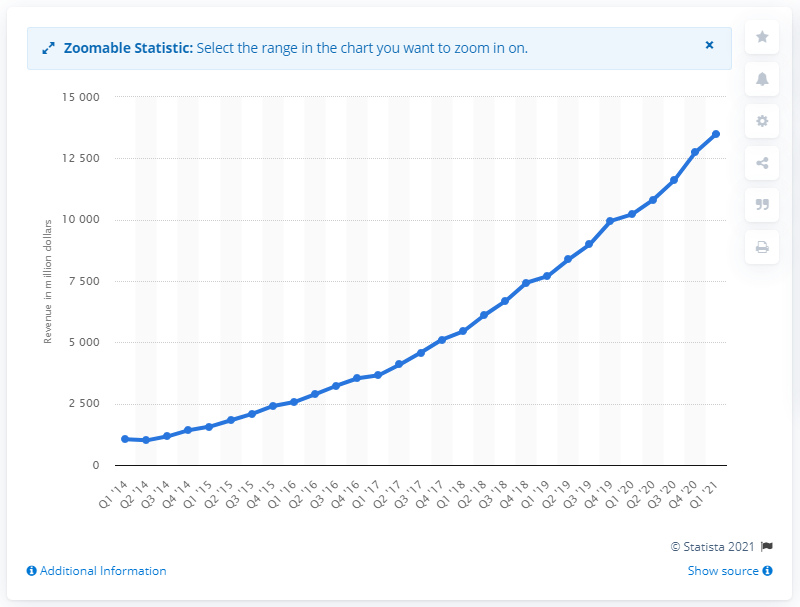Identify some key points in this picture. In the first quarter of 2021, Amazon Web Services (AWS) generated approximately $135.03 billion in revenue. 